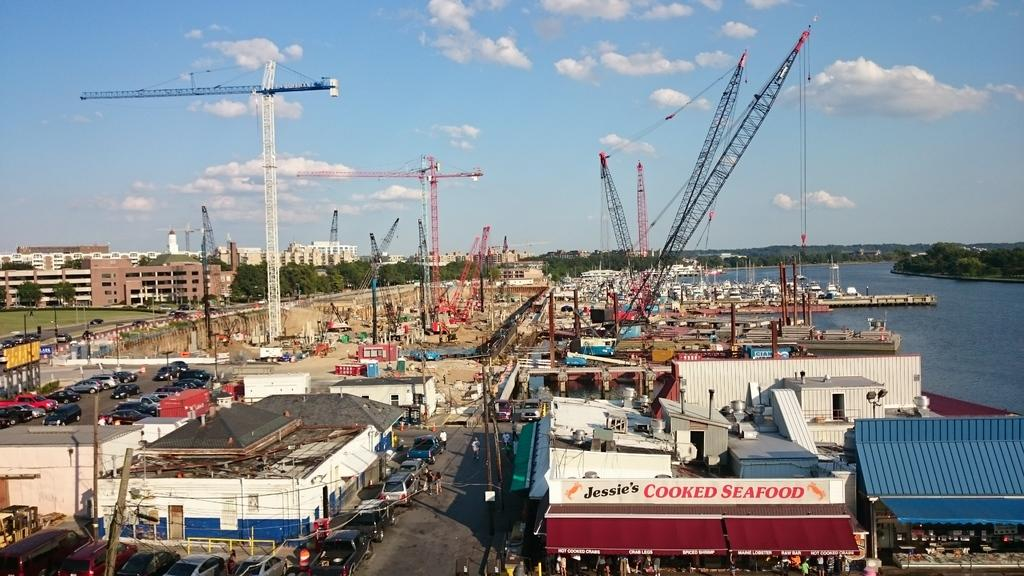What type of structures can be seen in the image? There are many buildings in the image. What else can be seen in the image besides buildings? There are many vehicles and tower cranes visible in the image. What can be seen in the background of the image? There are trees, water, and the sky visible in the background of the image. What is the condition of the sky in the image? The sky is visible in the background of the image, and clouds are present. How many books are stacked on the boat in the image? There is no boat or books present in the image. What are the hands of the people in the image doing? There are no people present in the image, so their hands cannot be observed. 